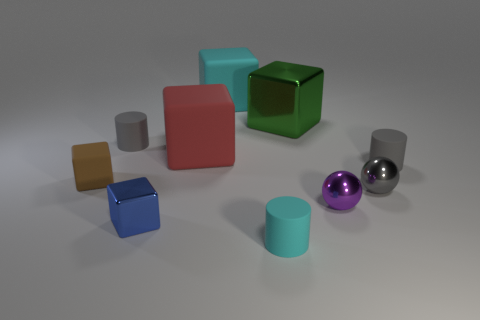Subtract all tiny rubber blocks. How many blocks are left? 4 Subtract all brown blocks. How many blocks are left? 4 Subtract all yellow blocks. Subtract all green cylinders. How many blocks are left? 5 Subtract all balls. How many objects are left? 8 Subtract all small gray metal objects. Subtract all cyan rubber cubes. How many objects are left? 8 Add 3 cyan blocks. How many cyan blocks are left? 4 Add 6 small gray metallic spheres. How many small gray metallic spheres exist? 7 Subtract 0 brown cylinders. How many objects are left? 10 